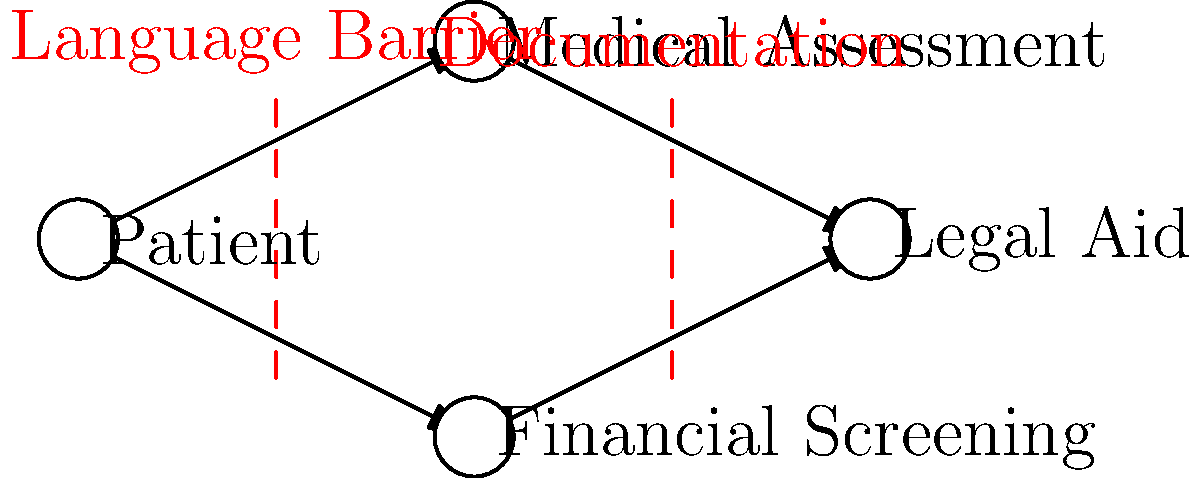In the diagram representing the pathways to accessing legal aid for patients with complex medical needs, what are the two main barriers identified, and at which stages do they occur? To answer this question, let's analyze the diagram step-by-step:

1. The diagram shows a flow from left to right, starting with the "Patient" and ending with "Legal Aid".

2. There are two main pathways from "Patient" to "Legal Aid":
   a. Patient → Medical Assessment → Legal Aid
   b. Patient → Financial Screening → Legal Aid

3. Two red dashed lines are present in the diagram, representing barriers:
   a. The first barrier is labeled "Language Barrier" and is positioned between "Patient" and both "Medical Assessment" and "Financial Screening".
   b. The second barrier is labeled "Documentation" and is positioned between both "Medical Assessment" and "Financial Screening", and "Legal Aid".

4. The stages at which these barriers occur:
   a. The Language Barrier occurs at the initial stage, potentially affecting both the medical assessment and financial screening processes.
   b. The Documentation barrier occurs at the final stage, potentially impeding access to legal aid after both medical assessment and financial screening.

Therefore, the two main barriers identified are the Language Barrier and Documentation, occurring at the initial and final stages of the process, respectively.
Answer: Language Barrier (initial stage) and Documentation (final stage) 